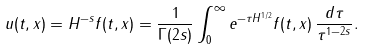<formula> <loc_0><loc_0><loc_500><loc_500>u ( t , x ) = H ^ { - s } f ( t , x ) = \frac { 1 } { \Gamma ( 2 s ) } \int _ { 0 } ^ { \infty } e ^ { - \tau H ^ { 1 / 2 } } f ( t , x ) \, \frac { d \tau } { \tau ^ { 1 - 2 s } } .</formula> 